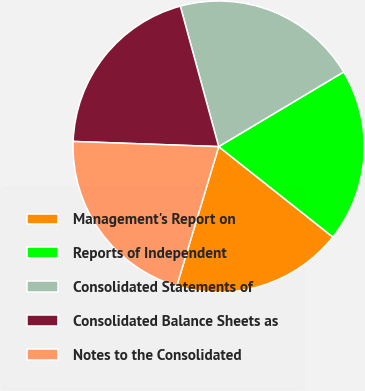Convert chart to OTSL. <chart><loc_0><loc_0><loc_500><loc_500><pie_chart><fcel>Management's Report on<fcel>Reports of Independent<fcel>Consolidated Statements of<fcel>Consolidated Balance Sheets as<fcel>Notes to the Consolidated<nl><fcel>18.99%<fcel>19.23%<fcel>20.67%<fcel>20.19%<fcel>20.91%<nl></chart> 